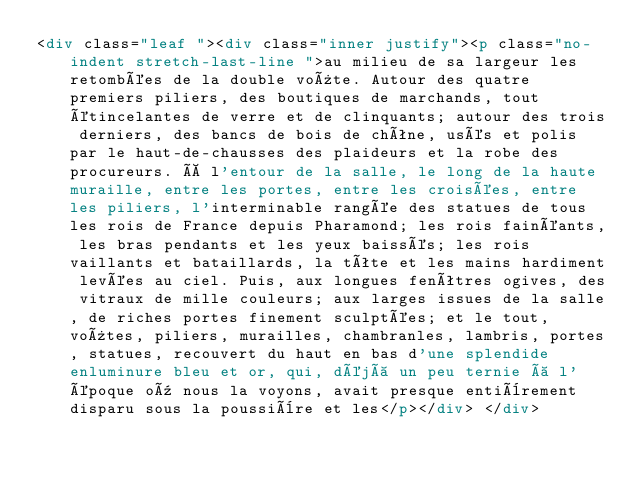Convert code to text. <code><loc_0><loc_0><loc_500><loc_500><_HTML_><div class="leaf "><div class="inner justify"><p class="no-indent stretch-last-line ">au milieu de sa largeur les retombées de la double voûte. Autour des quatre premiers piliers, des boutiques de marchands, tout étincelantes de verre et de clinquants; autour des trois derniers, des bancs de bois de chêne, usés et polis par le haut-de-chausses des plaideurs et la robe des procureurs. À l'entour de la salle, le long de la haute muraille, entre les portes, entre les croisées, entre les piliers, l'interminable rangée des statues de tous les rois de France depuis Pharamond; les rois fainéants, les bras pendants et les yeux baissés; les rois vaillants et bataillards, la tête et les mains hardiment levées au ciel. Puis, aux longues fenêtres ogives, des vitraux de mille couleurs; aux larges issues de la salle, de riches portes finement sculptées; et le tout, voûtes, piliers, murailles, chambranles, lambris, portes, statues, recouvert du haut en bas d'une splendide enluminure bleu et or, qui, déjà un peu ternie à l'époque où nous la voyons, avait presque entièrement disparu sous la poussière et les</p></div> </div></code> 